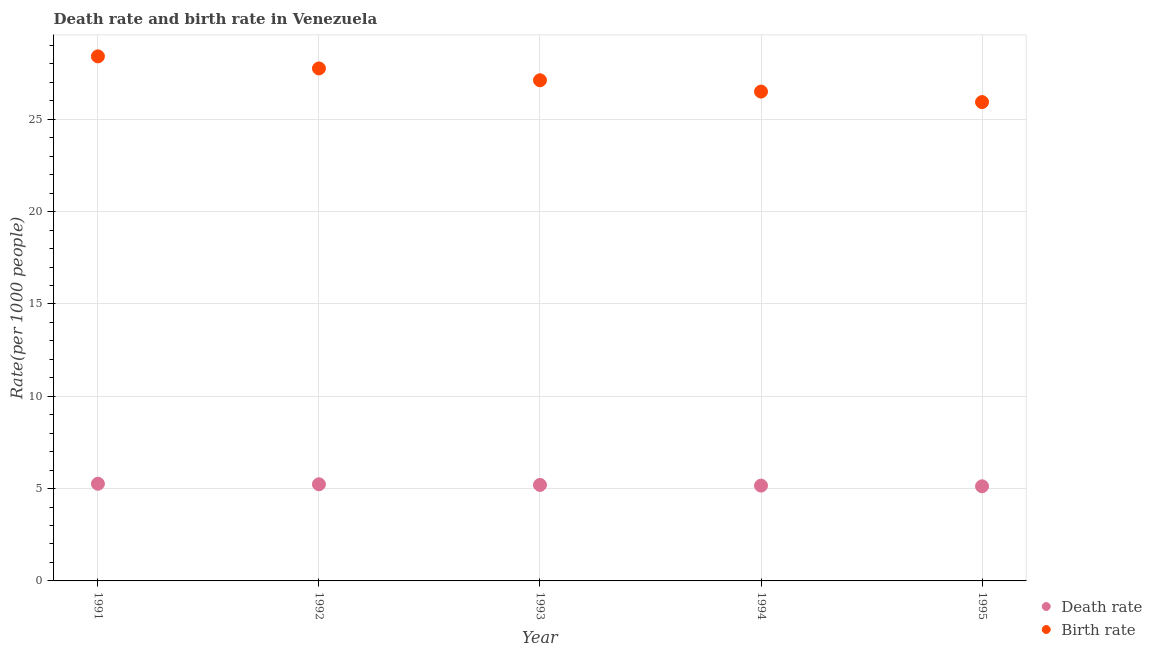What is the birth rate in 1994?
Your response must be concise. 26.5. Across all years, what is the maximum birth rate?
Make the answer very short. 28.41. Across all years, what is the minimum death rate?
Provide a succinct answer. 5.12. In which year was the death rate maximum?
Offer a very short reply. 1991. In which year was the death rate minimum?
Your answer should be very brief. 1995. What is the total death rate in the graph?
Provide a succinct answer. 25.99. What is the difference between the death rate in 1992 and that in 1994?
Your response must be concise. 0.07. What is the difference between the death rate in 1993 and the birth rate in 1991?
Offer a terse response. -23.21. What is the average birth rate per year?
Offer a terse response. 27.15. In the year 1993, what is the difference between the death rate and birth rate?
Make the answer very short. -21.92. What is the ratio of the birth rate in 1993 to that in 1994?
Your answer should be very brief. 1.02. Is the birth rate in 1992 less than that in 1993?
Offer a terse response. No. Is the difference between the death rate in 1991 and 1994 greater than the difference between the birth rate in 1991 and 1994?
Your answer should be very brief. No. What is the difference between the highest and the second highest death rate?
Give a very brief answer. 0.03. What is the difference between the highest and the lowest death rate?
Offer a very short reply. 0.14. Is the death rate strictly less than the birth rate over the years?
Make the answer very short. Yes. How many years are there in the graph?
Ensure brevity in your answer.  5. Are the values on the major ticks of Y-axis written in scientific E-notation?
Ensure brevity in your answer.  No. Does the graph contain grids?
Offer a terse response. Yes. Where does the legend appear in the graph?
Offer a terse response. Bottom right. How many legend labels are there?
Your response must be concise. 2. What is the title of the graph?
Your answer should be compact. Death rate and birth rate in Venezuela. What is the label or title of the Y-axis?
Provide a short and direct response. Rate(per 1000 people). What is the Rate(per 1000 people) in Death rate in 1991?
Give a very brief answer. 5.26. What is the Rate(per 1000 people) in Birth rate in 1991?
Your answer should be very brief. 28.41. What is the Rate(per 1000 people) in Death rate in 1992?
Your answer should be very brief. 5.23. What is the Rate(per 1000 people) of Birth rate in 1992?
Offer a very short reply. 27.76. What is the Rate(per 1000 people) in Death rate in 1993?
Offer a very short reply. 5.2. What is the Rate(per 1000 people) in Birth rate in 1993?
Provide a succinct answer. 27.12. What is the Rate(per 1000 people) in Death rate in 1994?
Your answer should be compact. 5.16. What is the Rate(per 1000 people) in Birth rate in 1994?
Ensure brevity in your answer.  26.5. What is the Rate(per 1000 people) of Death rate in 1995?
Ensure brevity in your answer.  5.12. What is the Rate(per 1000 people) of Birth rate in 1995?
Give a very brief answer. 25.94. Across all years, what is the maximum Rate(per 1000 people) in Death rate?
Ensure brevity in your answer.  5.26. Across all years, what is the maximum Rate(per 1000 people) in Birth rate?
Keep it short and to the point. 28.41. Across all years, what is the minimum Rate(per 1000 people) in Death rate?
Your response must be concise. 5.12. Across all years, what is the minimum Rate(per 1000 people) of Birth rate?
Provide a short and direct response. 25.94. What is the total Rate(per 1000 people) of Death rate in the graph?
Offer a terse response. 25.99. What is the total Rate(per 1000 people) of Birth rate in the graph?
Provide a succinct answer. 135.73. What is the difference between the Rate(per 1000 people) in Birth rate in 1991 and that in 1992?
Keep it short and to the point. 0.65. What is the difference between the Rate(per 1000 people) of Death rate in 1991 and that in 1993?
Your response must be concise. 0.06. What is the difference between the Rate(per 1000 people) of Birth rate in 1991 and that in 1993?
Your answer should be compact. 1.29. What is the difference between the Rate(per 1000 people) in Death rate in 1991 and that in 1994?
Provide a short and direct response. 0.1. What is the difference between the Rate(per 1000 people) of Birth rate in 1991 and that in 1994?
Give a very brief answer. 1.91. What is the difference between the Rate(per 1000 people) in Death rate in 1991 and that in 1995?
Give a very brief answer. 0.14. What is the difference between the Rate(per 1000 people) in Birth rate in 1991 and that in 1995?
Ensure brevity in your answer.  2.48. What is the difference between the Rate(per 1000 people) of Death rate in 1992 and that in 1993?
Your response must be concise. 0.03. What is the difference between the Rate(per 1000 people) in Birth rate in 1992 and that in 1993?
Offer a very short reply. 0.64. What is the difference between the Rate(per 1000 people) in Death rate in 1992 and that in 1994?
Make the answer very short. 0.07. What is the difference between the Rate(per 1000 people) in Birth rate in 1992 and that in 1994?
Give a very brief answer. 1.25. What is the difference between the Rate(per 1000 people) in Death rate in 1992 and that in 1995?
Provide a short and direct response. 0.11. What is the difference between the Rate(per 1000 people) of Birth rate in 1992 and that in 1995?
Your answer should be very brief. 1.82. What is the difference between the Rate(per 1000 people) of Death rate in 1993 and that in 1994?
Give a very brief answer. 0.04. What is the difference between the Rate(per 1000 people) of Birth rate in 1993 and that in 1994?
Your answer should be compact. 0.61. What is the difference between the Rate(per 1000 people) in Death rate in 1993 and that in 1995?
Your answer should be very brief. 0.07. What is the difference between the Rate(per 1000 people) in Birth rate in 1993 and that in 1995?
Provide a short and direct response. 1.18. What is the difference between the Rate(per 1000 people) in Death rate in 1994 and that in 1995?
Keep it short and to the point. 0.04. What is the difference between the Rate(per 1000 people) of Birth rate in 1994 and that in 1995?
Your response must be concise. 0.57. What is the difference between the Rate(per 1000 people) in Death rate in 1991 and the Rate(per 1000 people) in Birth rate in 1992?
Ensure brevity in your answer.  -22.5. What is the difference between the Rate(per 1000 people) of Death rate in 1991 and the Rate(per 1000 people) of Birth rate in 1993?
Your answer should be compact. -21.85. What is the difference between the Rate(per 1000 people) of Death rate in 1991 and the Rate(per 1000 people) of Birth rate in 1994?
Make the answer very short. -21.24. What is the difference between the Rate(per 1000 people) in Death rate in 1991 and the Rate(per 1000 people) in Birth rate in 1995?
Offer a terse response. -20.67. What is the difference between the Rate(per 1000 people) of Death rate in 1992 and the Rate(per 1000 people) of Birth rate in 1993?
Ensure brevity in your answer.  -21.88. What is the difference between the Rate(per 1000 people) in Death rate in 1992 and the Rate(per 1000 people) in Birth rate in 1994?
Your answer should be very brief. -21.27. What is the difference between the Rate(per 1000 people) in Death rate in 1992 and the Rate(per 1000 people) in Birth rate in 1995?
Give a very brief answer. -20.7. What is the difference between the Rate(per 1000 people) of Death rate in 1993 and the Rate(per 1000 people) of Birth rate in 1994?
Give a very brief answer. -21.3. What is the difference between the Rate(per 1000 people) in Death rate in 1993 and the Rate(per 1000 people) in Birth rate in 1995?
Give a very brief answer. -20.74. What is the difference between the Rate(per 1000 people) of Death rate in 1994 and the Rate(per 1000 people) of Birth rate in 1995?
Give a very brief answer. -20.77. What is the average Rate(per 1000 people) in Death rate per year?
Provide a succinct answer. 5.2. What is the average Rate(per 1000 people) in Birth rate per year?
Offer a very short reply. 27.15. In the year 1991, what is the difference between the Rate(per 1000 people) in Death rate and Rate(per 1000 people) in Birth rate?
Make the answer very short. -23.15. In the year 1992, what is the difference between the Rate(per 1000 people) of Death rate and Rate(per 1000 people) of Birth rate?
Provide a short and direct response. -22.52. In the year 1993, what is the difference between the Rate(per 1000 people) in Death rate and Rate(per 1000 people) in Birth rate?
Ensure brevity in your answer.  -21.92. In the year 1994, what is the difference between the Rate(per 1000 people) of Death rate and Rate(per 1000 people) of Birth rate?
Your response must be concise. -21.34. In the year 1995, what is the difference between the Rate(per 1000 people) of Death rate and Rate(per 1000 people) of Birth rate?
Make the answer very short. -20.81. What is the ratio of the Rate(per 1000 people) of Birth rate in 1991 to that in 1992?
Your answer should be very brief. 1.02. What is the ratio of the Rate(per 1000 people) in Death rate in 1991 to that in 1993?
Your response must be concise. 1.01. What is the ratio of the Rate(per 1000 people) of Birth rate in 1991 to that in 1993?
Ensure brevity in your answer.  1.05. What is the ratio of the Rate(per 1000 people) in Death rate in 1991 to that in 1994?
Provide a short and direct response. 1.02. What is the ratio of the Rate(per 1000 people) in Birth rate in 1991 to that in 1994?
Your answer should be compact. 1.07. What is the ratio of the Rate(per 1000 people) in Death rate in 1991 to that in 1995?
Your answer should be very brief. 1.03. What is the ratio of the Rate(per 1000 people) in Birth rate in 1991 to that in 1995?
Provide a short and direct response. 1.1. What is the ratio of the Rate(per 1000 people) in Birth rate in 1992 to that in 1993?
Your response must be concise. 1.02. What is the ratio of the Rate(per 1000 people) in Death rate in 1992 to that in 1994?
Offer a very short reply. 1.01. What is the ratio of the Rate(per 1000 people) of Birth rate in 1992 to that in 1994?
Offer a terse response. 1.05. What is the ratio of the Rate(per 1000 people) in Death rate in 1992 to that in 1995?
Make the answer very short. 1.02. What is the ratio of the Rate(per 1000 people) of Birth rate in 1992 to that in 1995?
Ensure brevity in your answer.  1.07. What is the ratio of the Rate(per 1000 people) in Birth rate in 1993 to that in 1994?
Keep it short and to the point. 1.02. What is the ratio of the Rate(per 1000 people) of Death rate in 1993 to that in 1995?
Give a very brief answer. 1.01. What is the ratio of the Rate(per 1000 people) in Birth rate in 1993 to that in 1995?
Make the answer very short. 1.05. What is the ratio of the Rate(per 1000 people) in Death rate in 1994 to that in 1995?
Give a very brief answer. 1.01. What is the ratio of the Rate(per 1000 people) in Birth rate in 1994 to that in 1995?
Provide a short and direct response. 1.02. What is the difference between the highest and the second highest Rate(per 1000 people) of Death rate?
Offer a terse response. 0.03. What is the difference between the highest and the second highest Rate(per 1000 people) in Birth rate?
Make the answer very short. 0.65. What is the difference between the highest and the lowest Rate(per 1000 people) of Death rate?
Your response must be concise. 0.14. What is the difference between the highest and the lowest Rate(per 1000 people) in Birth rate?
Provide a short and direct response. 2.48. 